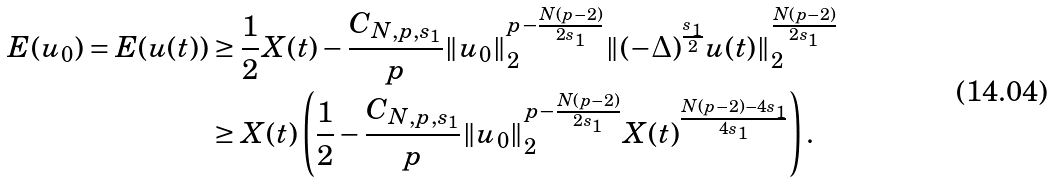<formula> <loc_0><loc_0><loc_500><loc_500>E ( u _ { 0 } ) = E ( u ( t ) ) & \geq \frac { 1 } { 2 } X ( t ) - \frac { C _ { N , p , s _ { 1 } } } { p } \| u _ { 0 } \| _ { 2 } ^ { p - \frac { N ( p - 2 ) } { 2 s _ { 1 } } } \| ( - \Delta ) ^ { \frac { s _ { 1 } } { 2 } } u ( t ) \| _ { 2 } ^ { \frac { N ( p - 2 ) } { 2 s _ { 1 } } } \\ & \geq X ( t ) \left ( \frac { 1 } { 2 } - \frac { C _ { N , p , s _ { 1 } } } { p } \| u _ { 0 } \| _ { 2 } ^ { p - \frac { N ( p - 2 ) } { 2 s _ { 1 } } } X ( t ) ^ { \frac { N ( p - 2 ) - 4 s _ { 1 } } { 4 s _ { 1 } } } \right ) .</formula> 